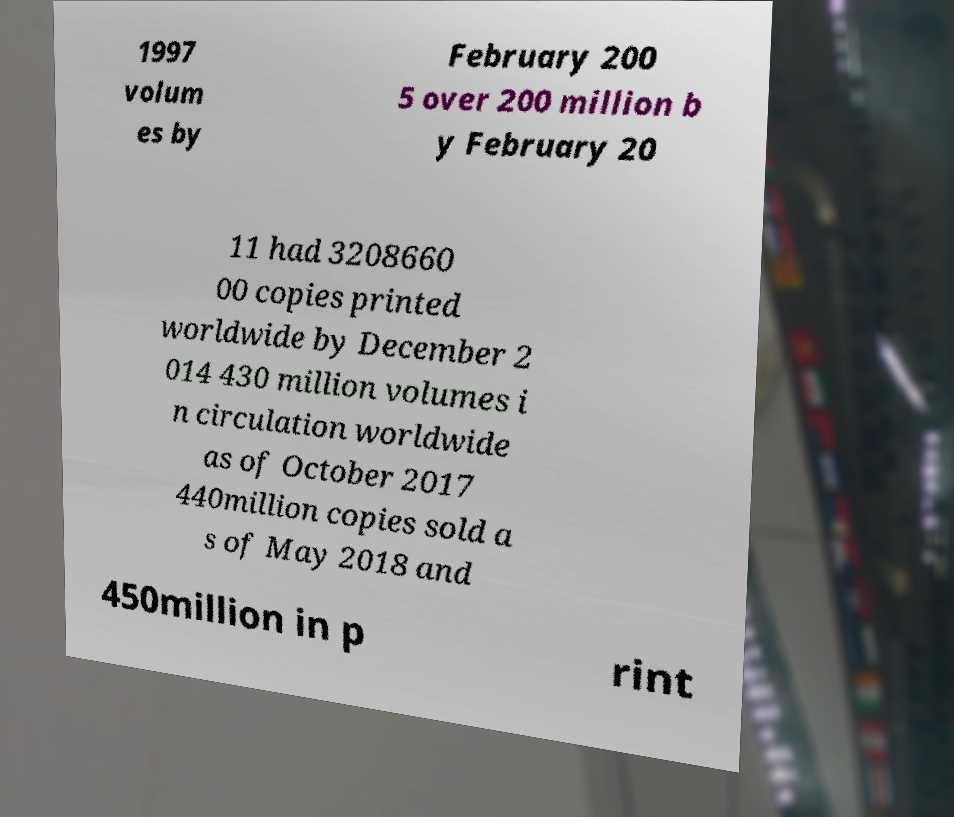I need the written content from this picture converted into text. Can you do that? 1997 volum es by February 200 5 over 200 million b y February 20 11 had 3208660 00 copies printed worldwide by December 2 014 430 million volumes i n circulation worldwide as of October 2017 440million copies sold a s of May 2018 and 450million in p rint 